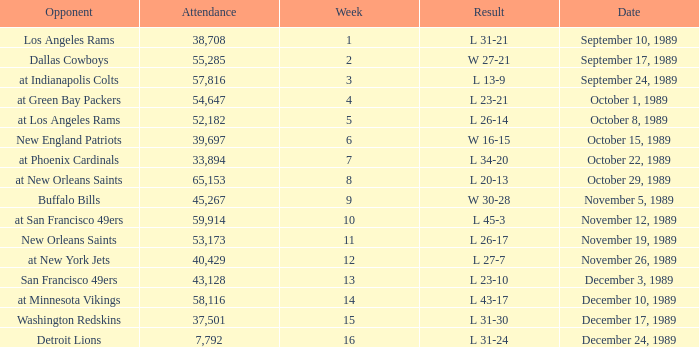For what week was the attendance 40,429? 12.0. 